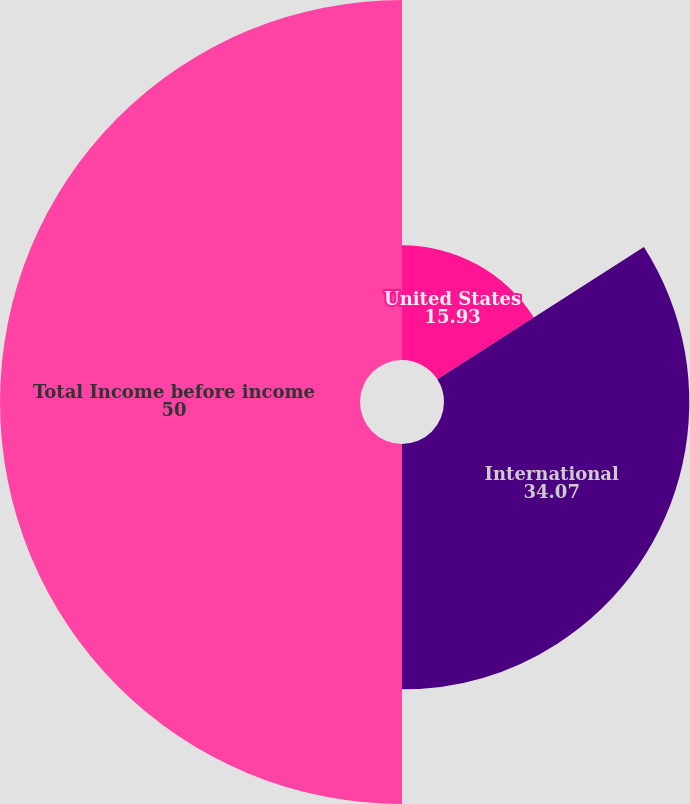Convert chart. <chart><loc_0><loc_0><loc_500><loc_500><pie_chart><fcel>United States<fcel>International<fcel>Total Income before income<nl><fcel>15.93%<fcel>34.07%<fcel>50.0%<nl></chart> 